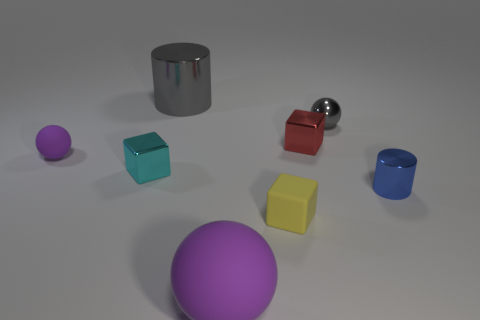The sphere that is behind the small cylinder and in front of the red thing is made of what material?
Provide a succinct answer. Rubber. There is a gray metal ball; is its size the same as the purple rubber thing that is behind the tiny yellow thing?
Give a very brief answer. Yes. Is there a brown metal object?
Ensure brevity in your answer.  No. There is another thing that is the same shape as the large gray thing; what is its material?
Keep it short and to the point. Metal. How big is the purple matte ball in front of the small matte object that is to the right of the ball that is to the left of the big shiny cylinder?
Give a very brief answer. Large. Are there any large cylinders in front of the big purple ball?
Ensure brevity in your answer.  No. What size is the cyan cube that is made of the same material as the blue thing?
Your response must be concise. Small. How many yellow things have the same shape as the tiny red thing?
Your response must be concise. 1. Is the material of the small gray sphere the same as the big thing that is in front of the tiny gray metal sphere?
Offer a very short reply. No. Is the number of small gray metal spheres to the left of the yellow thing greater than the number of tiny brown metal objects?
Give a very brief answer. No. 